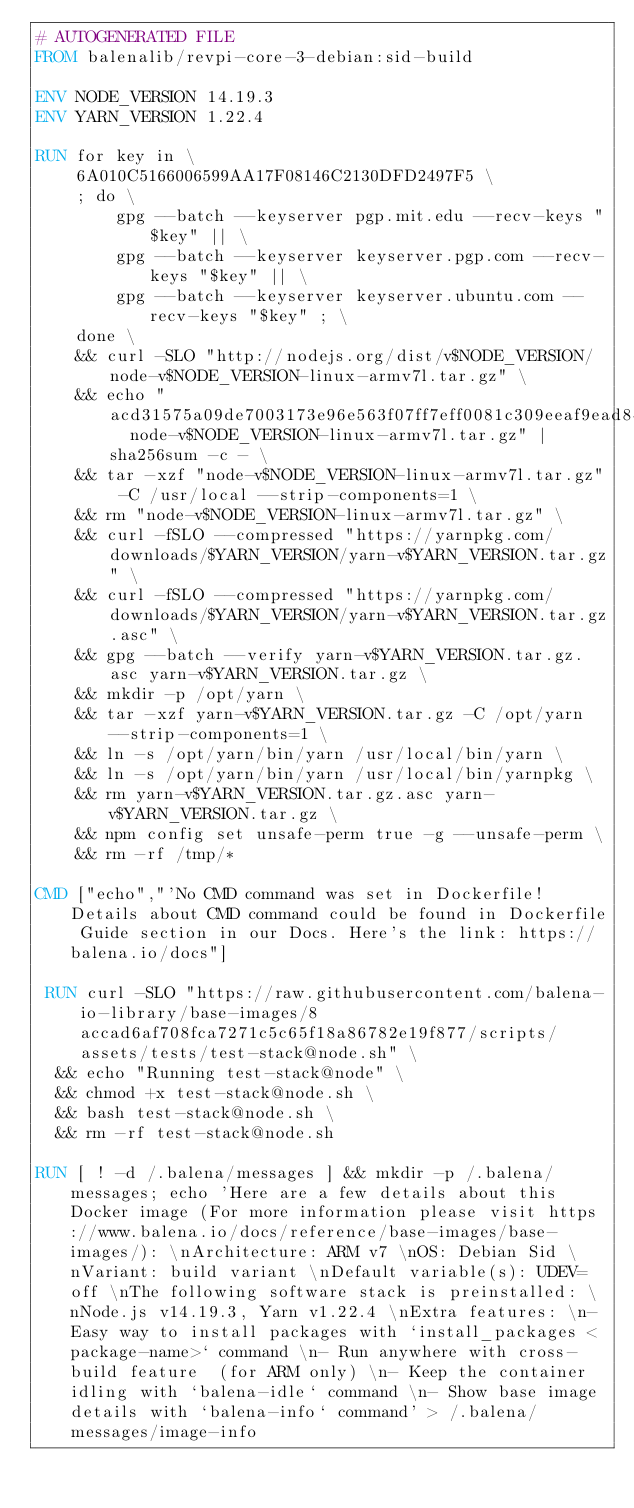<code> <loc_0><loc_0><loc_500><loc_500><_Dockerfile_># AUTOGENERATED FILE
FROM balenalib/revpi-core-3-debian:sid-build

ENV NODE_VERSION 14.19.3
ENV YARN_VERSION 1.22.4

RUN for key in \
	6A010C5166006599AA17F08146C2130DFD2497F5 \
	; do \
		gpg --batch --keyserver pgp.mit.edu --recv-keys "$key" || \
		gpg --batch --keyserver keyserver.pgp.com --recv-keys "$key" || \
		gpg --batch --keyserver keyserver.ubuntu.com --recv-keys "$key" ; \
	done \
	&& curl -SLO "http://nodejs.org/dist/v$NODE_VERSION/node-v$NODE_VERSION-linux-armv7l.tar.gz" \
	&& echo "acd31575a09de7003173e96e563f07ff7eff0081c309eeaf9ead846baa6743ea  node-v$NODE_VERSION-linux-armv7l.tar.gz" | sha256sum -c - \
	&& tar -xzf "node-v$NODE_VERSION-linux-armv7l.tar.gz" -C /usr/local --strip-components=1 \
	&& rm "node-v$NODE_VERSION-linux-armv7l.tar.gz" \
	&& curl -fSLO --compressed "https://yarnpkg.com/downloads/$YARN_VERSION/yarn-v$YARN_VERSION.tar.gz" \
	&& curl -fSLO --compressed "https://yarnpkg.com/downloads/$YARN_VERSION/yarn-v$YARN_VERSION.tar.gz.asc" \
	&& gpg --batch --verify yarn-v$YARN_VERSION.tar.gz.asc yarn-v$YARN_VERSION.tar.gz \
	&& mkdir -p /opt/yarn \
	&& tar -xzf yarn-v$YARN_VERSION.tar.gz -C /opt/yarn --strip-components=1 \
	&& ln -s /opt/yarn/bin/yarn /usr/local/bin/yarn \
	&& ln -s /opt/yarn/bin/yarn /usr/local/bin/yarnpkg \
	&& rm yarn-v$YARN_VERSION.tar.gz.asc yarn-v$YARN_VERSION.tar.gz \
	&& npm config set unsafe-perm true -g --unsafe-perm \
	&& rm -rf /tmp/*

CMD ["echo","'No CMD command was set in Dockerfile! Details about CMD command could be found in Dockerfile Guide section in our Docs. Here's the link: https://balena.io/docs"]

 RUN curl -SLO "https://raw.githubusercontent.com/balena-io-library/base-images/8accad6af708fca7271c5c65f18a86782e19f877/scripts/assets/tests/test-stack@node.sh" \
  && echo "Running test-stack@node" \
  && chmod +x test-stack@node.sh \
  && bash test-stack@node.sh \
  && rm -rf test-stack@node.sh 

RUN [ ! -d /.balena/messages ] && mkdir -p /.balena/messages; echo 'Here are a few details about this Docker image (For more information please visit https://www.balena.io/docs/reference/base-images/base-images/): \nArchitecture: ARM v7 \nOS: Debian Sid \nVariant: build variant \nDefault variable(s): UDEV=off \nThe following software stack is preinstalled: \nNode.js v14.19.3, Yarn v1.22.4 \nExtra features: \n- Easy way to install packages with `install_packages <package-name>` command \n- Run anywhere with cross-build feature  (for ARM only) \n- Keep the container idling with `balena-idle` command \n- Show base image details with `balena-info` command' > /.balena/messages/image-info</code> 